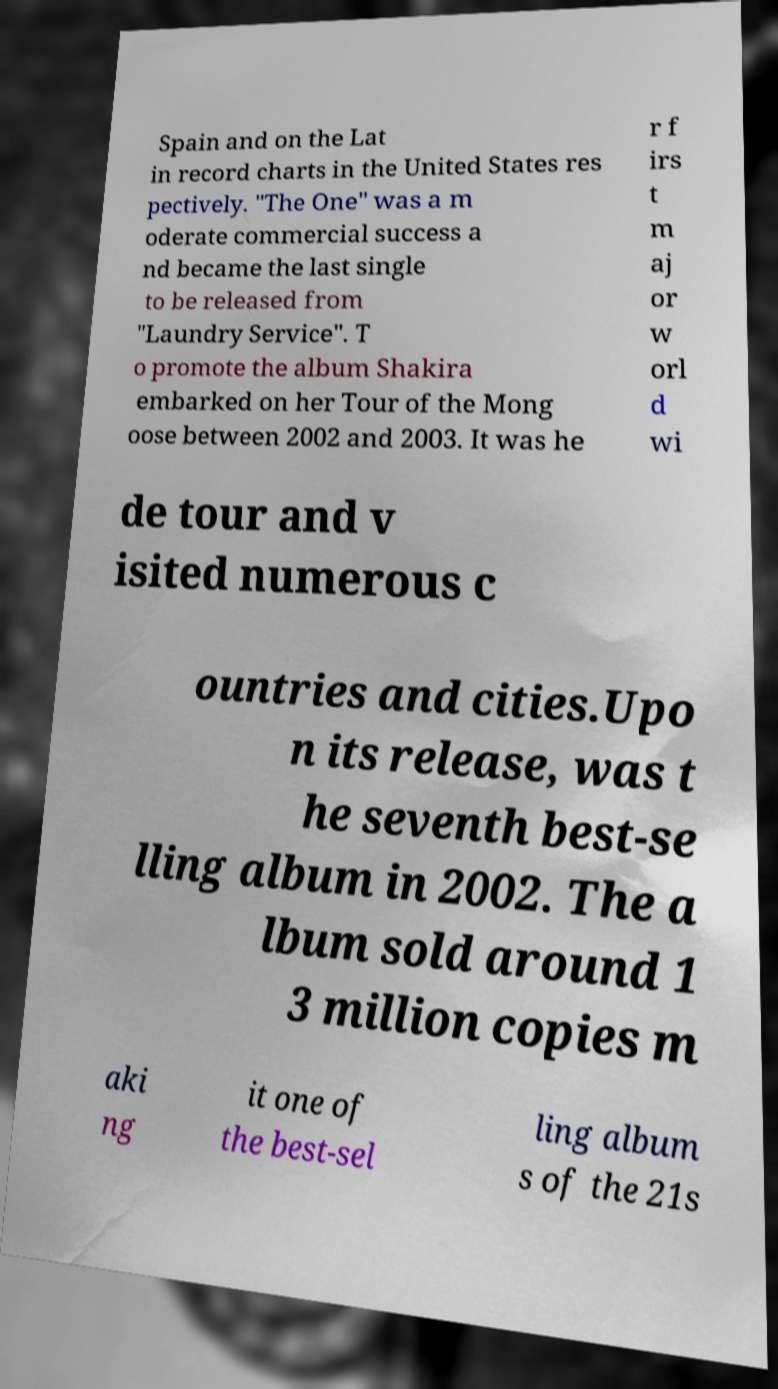Can you read and provide the text displayed in the image?This photo seems to have some interesting text. Can you extract and type it out for me? Spain and on the Lat in record charts in the United States res pectively. "The One" was a m oderate commercial success a nd became the last single to be released from "Laundry Service". T o promote the album Shakira embarked on her Tour of the Mong oose between 2002 and 2003. It was he r f irs t m aj or w orl d wi de tour and v isited numerous c ountries and cities.Upo n its release, was t he seventh best-se lling album in 2002. The a lbum sold around 1 3 million copies m aki ng it one of the best-sel ling album s of the 21s 